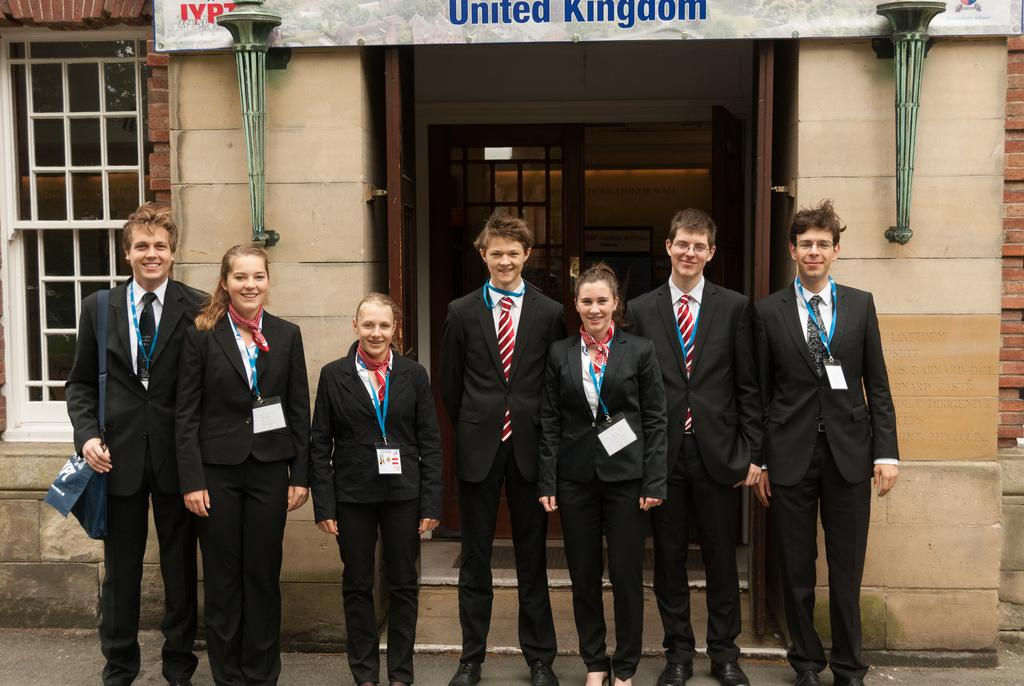What are the people in the image doing? The people in the image are standing on the road. What can be seen in the background of the image? In the background of the image, there are walls, at least one window, doors, boards, and other objects. Can you describe the walls in the background? The walls are part of the background and provide a sense of the surrounding environment. What time of day is it in the image, and how does the dust affect the visibility? The provided facts do not mention the time of day or the presence of dust in the image. Therefore, we cannot determine the time of day or the visibility based on the given information. 